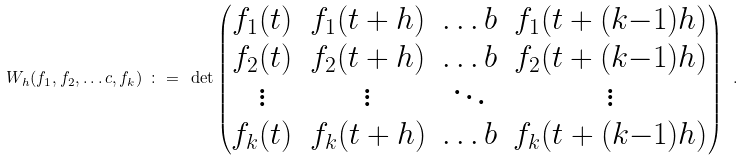<formula> <loc_0><loc_0><loc_500><loc_500>\ W _ { h } ( f _ { 1 } , f _ { 2 } , \dots c , f _ { k } ) \ \colon = \ \det \left ( \begin{matrix} f _ { 1 } ( t ) & f _ { 1 } ( t + h ) & \dots b & f _ { 1 } ( t + ( k { - } 1 ) h ) \\ f _ { 2 } ( t ) & f _ { 2 } ( t + h ) & \dots b & f _ { 2 } ( t + ( k { - } 1 ) h ) \\ \vdots & \vdots & \ddots & \vdots \\ f _ { k } ( t ) & f _ { k } ( t + h ) & \dots b & f _ { k } ( t + ( k { - } 1 ) h ) \\ \end{matrix} \right ) \ .</formula> 